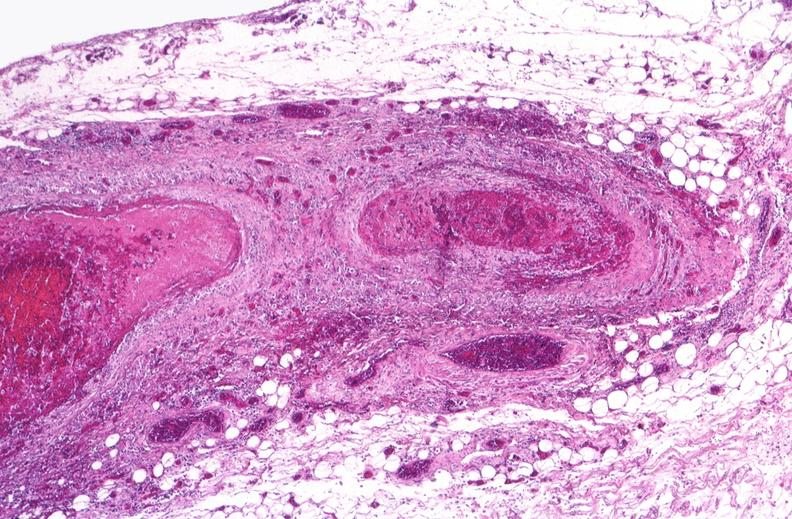what is present?
Answer the question using a single word or phrase. Cardiovascular 